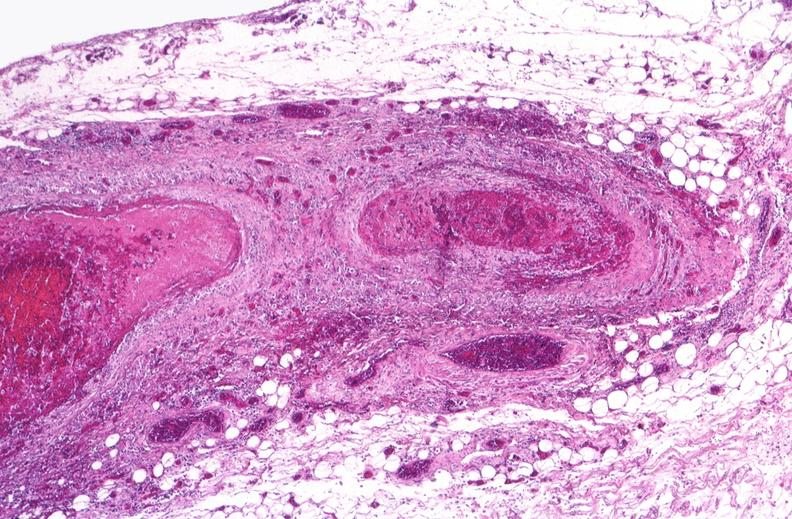what is present?
Answer the question using a single word or phrase. Cardiovascular 